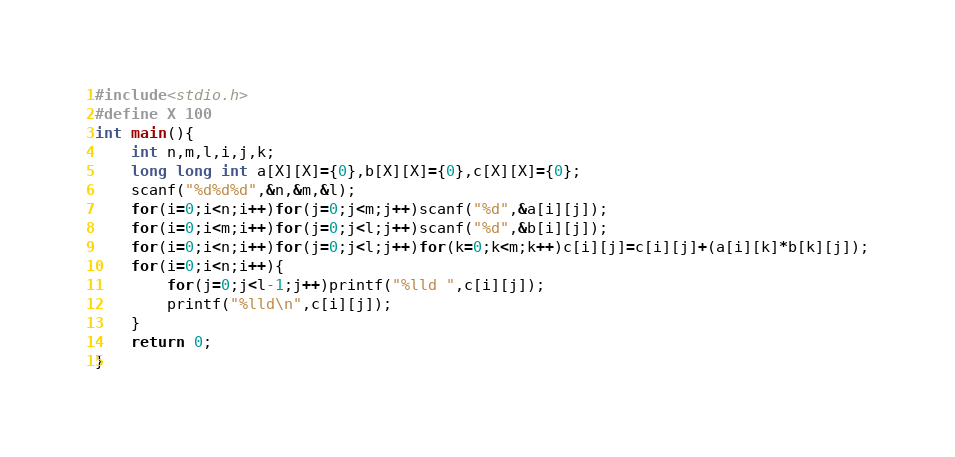Convert code to text. <code><loc_0><loc_0><loc_500><loc_500><_C_>#include<stdio.h>
#define X 100
int main(){
	int n,m,l,i,j,k;
	long long int a[X][X]={0},b[X][X]={0},c[X][X]={0};
	scanf("%d%d%d",&n,&m,&l);
	for(i=0;i<n;i++)for(j=0;j<m;j++)scanf("%d",&a[i][j]);
	for(i=0;i<m;i++)for(j=0;j<l;j++)scanf("%d",&b[i][j]);
	for(i=0;i<n;i++)for(j=0;j<l;j++)for(k=0;k<m;k++)c[i][j]=c[i][j]+(a[i][k]*b[k][j]);
	for(i=0;i<n;i++){
		for(j=0;j<l-1;j++)printf("%lld ",c[i][j]);
		printf("%lld\n",c[i][j]);
	}
	return 0;
}

</code> 